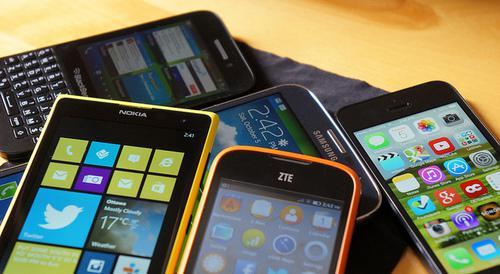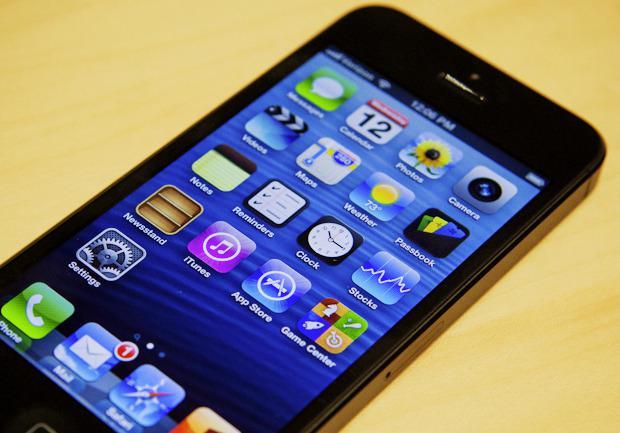The first image is the image on the left, the second image is the image on the right. Evaluate the accuracy of this statement regarding the images: "One of the phones reads 2:42 PM.". Is it true? Answer yes or no. Yes. The first image is the image on the left, the second image is the image on the right. Considering the images on both sides, is "A group of phones lies together in the image on the right." valid? Answer yes or no. No. 